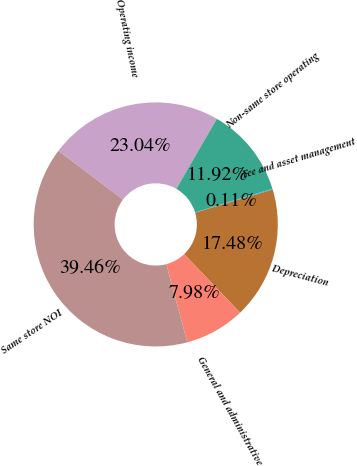Convert chart to OTSL. <chart><loc_0><loc_0><loc_500><loc_500><pie_chart><fcel>Operating income<fcel>Non-same store operating<fcel>Fee and asset management<fcel>Depreciation<fcel>General and administrative<fcel>Same store NOI<nl><fcel>23.04%<fcel>11.92%<fcel>0.11%<fcel>17.48%<fcel>7.98%<fcel>39.46%<nl></chart> 